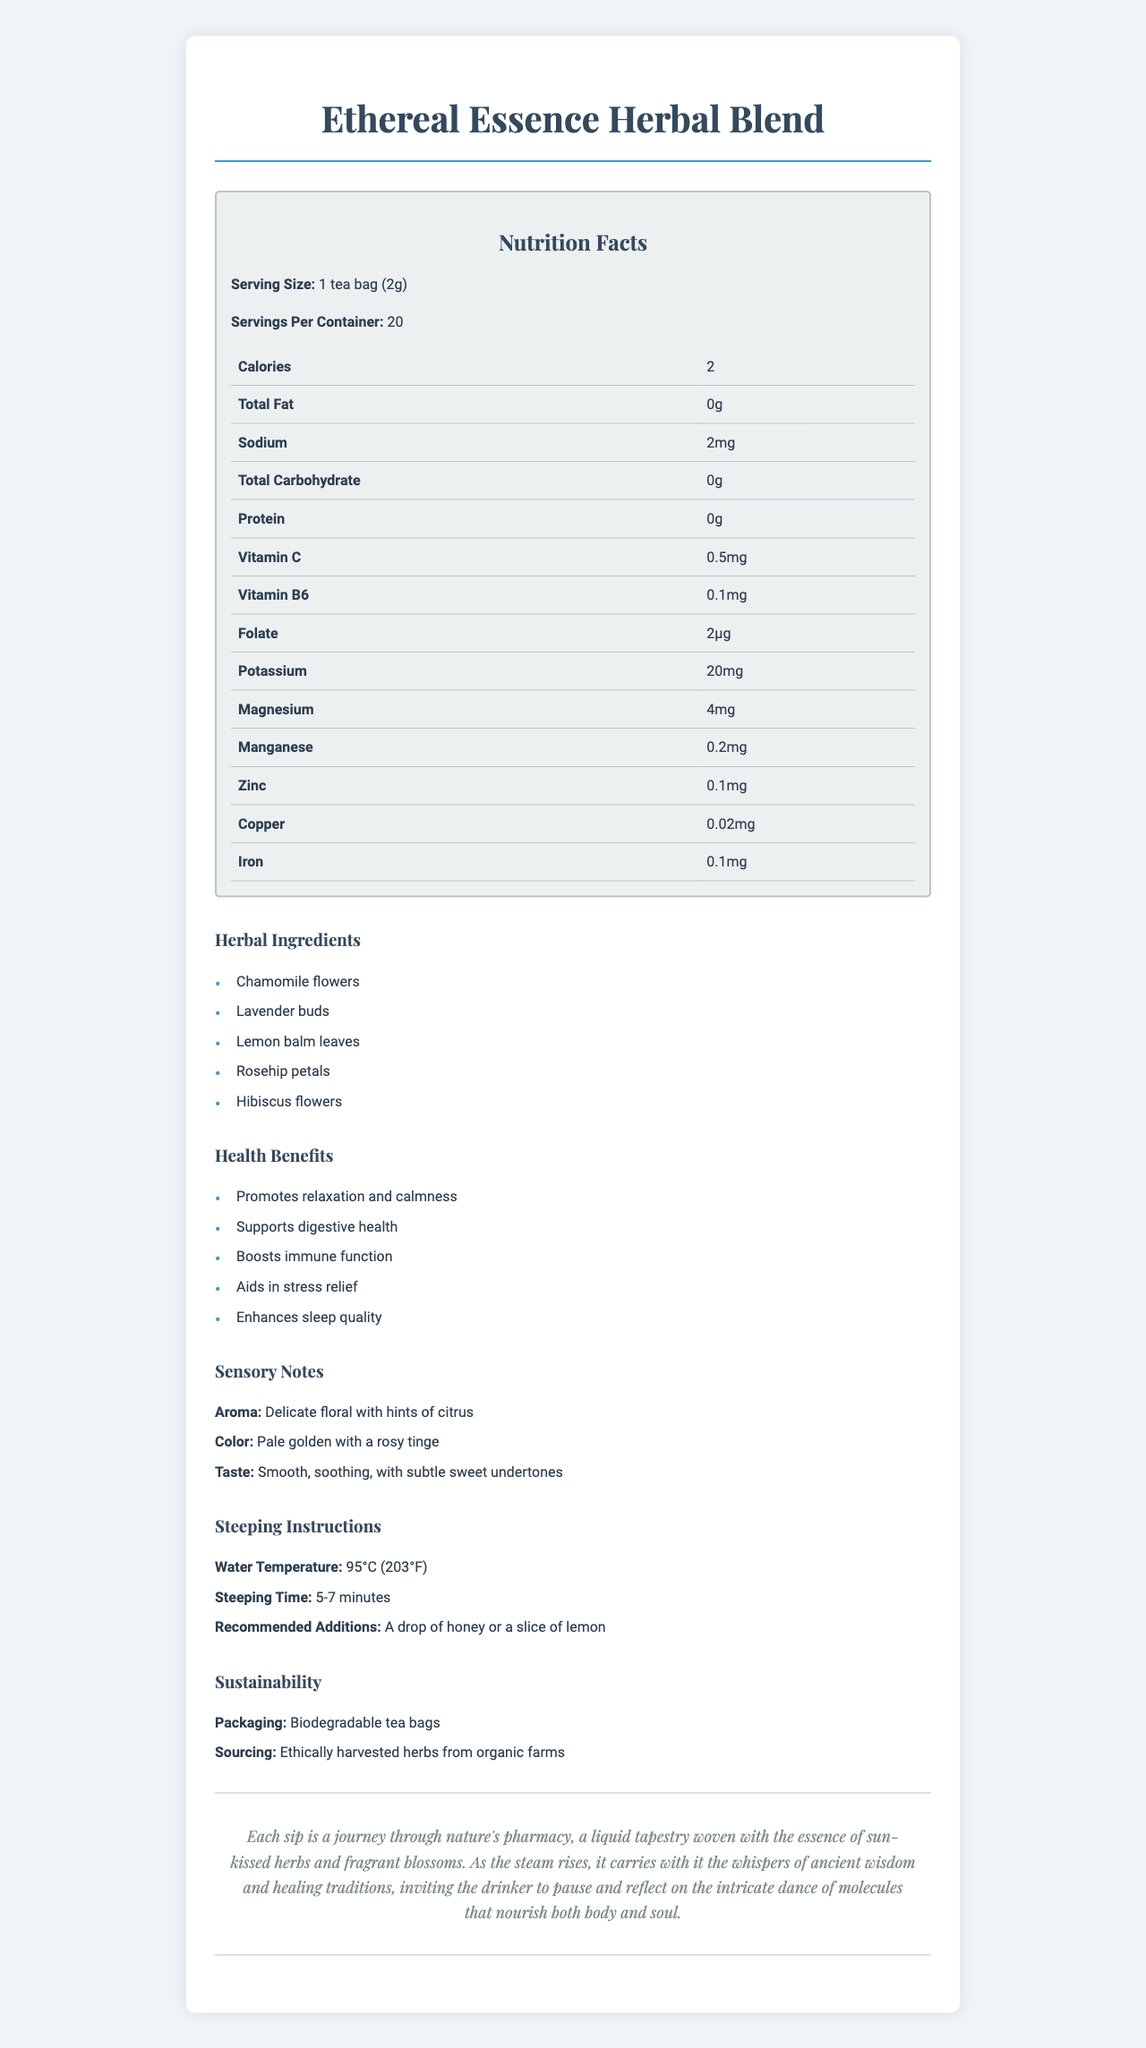what is the serving size of Ethereal Essence Herbal Blend? The serving size is stated directly under the Nutrition Facts title.
Answer: 1 tea bag (2g) how many servings are there per container? The number of servings per container is mentioned below the serving size.
Answer: 20 how much potassium is in one serving of Ethereal Essence Herbal Blend? The amount of potassium can be found in the nutrition facts table.
Answer: 20mg which ingredient in Ethereal Essence Herbal Blend is likely the main contributor to its delicate floral aroma? This can be inferred from the sensory notes that describe the aroma and the list of herbal ingredients.
Answer: Lavender buds list two health benefits of drinking Ethereal Essence Herbal Blend. These benefits are provided in the health benefits section.
Answer: Promotes relaxation and calmness, Supports digestive health which of the following is a recommended addition to enhance the flavor of the tea? A. Sugar B. Milk C. Honey The recommended additions are specified under the steeping instructions.
Answer: C. Honey how many carbs are in a serving? The total carbohydrate amount is listed in the nutrition facts table.
Answer: 0g true or false: The tea helps in boosting immune function. This health benefit is explicitly listed in the health benefits section.
Answer: True what is the general color of the tea as described in the sensory notes? This is described in the sensory notes section of the document.
Answer: Pale golden with a rosy tinge what kind of packaging is used for Ethereal Essence Herbal Blend? The information regarding packaging is mentioned under the sustainability section.
Answer: Biodegradable tea bags which of these is NOT a benefit of Ethereal Essence Herbal Blend? A. Enhances mental clarity B. Supports digestive health C. Enhances sleep quality This benefit is not listed; the correct options are listed under health benefits.
Answer: A. Enhances mental clarity what is the steeping time for Ethereal Essence Herbal Blend? This detail can be found in the steeping instructions section.
Answer: 5-7 minutes summarize the main idea of the document. The summary captures the essence of the tea, its components, benefits, sensory characteristics, and preparation instructions as detailed in the document.
Answer: Ethereal Essence Herbal Blend is a carefully crafted herbal tea composed of chamomile, lavender, lemon balm, rosehip, and hibiscus. The tea is intended to promote relaxation, digestive health, and immune function, while offering a delicately floral aroma and pale golden hue with a rosy tinge. The tea contains a variety of micronutrients, and it is recommended to be steeped in hot water for 5-7 minutes. The product is sustainably packaged and ethically sourced. how does Ethereal Essence Herbal Blend contribute to stress relief? The document mentions that the tea aids in stress relief but does not provide specific details on how it achieves this effect.
Answer: Not enough information 